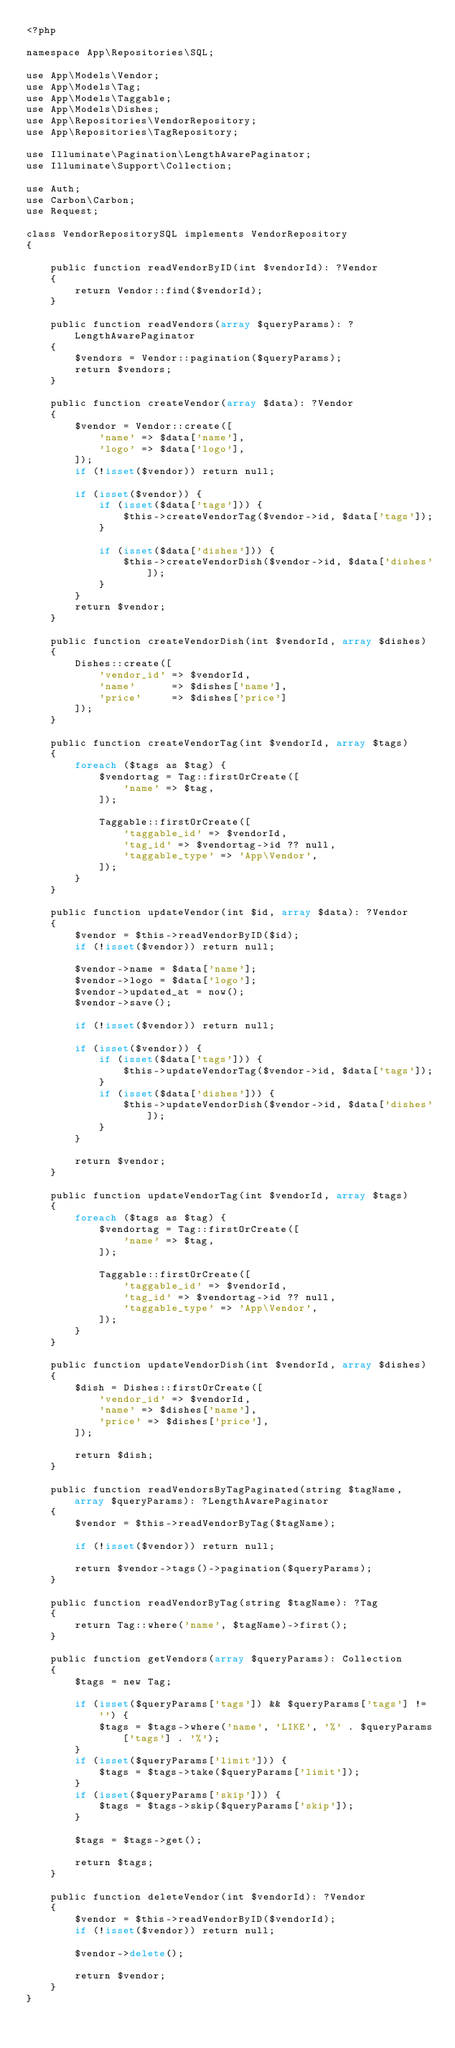<code> <loc_0><loc_0><loc_500><loc_500><_PHP_><?php

namespace App\Repositories\SQL;

use App\Models\Vendor;
use App\Models\Tag;
use App\Models\Taggable;
use App\Models\Dishes;
use App\Repositories\VendorRepository;
use App\Repositories\TagRepository;

use Illuminate\Pagination\LengthAwarePaginator;
use Illuminate\Support\Collection;

use Auth;
use Carbon\Carbon;
use Request;

class VendorRepositorySQL implements VendorRepository
{

    public function readVendorByID(int $vendorId): ?Vendor
    {
        return Vendor::find($vendorId);
    }

    public function readVendors(array $queryParams): ?LengthAwarePaginator
    {
        $vendors = Vendor::pagination($queryParams);
        return $vendors;
    }

    public function createVendor(array $data): ?Vendor
    {
        $vendor = Vendor::create([
            'name' => $data['name'],
            'logo' => $data['logo'],
        ]);
        if (!isset($vendor)) return null;

        if (isset($vendor)) {
            if (isset($data['tags'])) {
                $this->createVendorTag($vendor->id, $data['tags']);
            }

            if (isset($data['dishes'])) {
                $this->createVendorDish($vendor->id, $data['dishes']);
            }
        }
        return $vendor;
    }

    public function createVendorDish(int $vendorId, array $dishes)
    {
        Dishes::create([
            'vendor_id' => $vendorId,
            'name'      => $dishes['name'],
            'price'     => $dishes['price']
        ]);
    }

    public function createVendorTag(int $vendorId, array $tags)
    {
        foreach ($tags as $tag) {
            $vendortag = Tag::firstOrCreate([
                'name' => $tag,
            ]);

            Taggable::firstOrCreate([
                'taggable_id' => $vendorId,
                'tag_id' => $vendortag->id ?? null,
                'taggable_type' => 'App\Vendor',
            ]);
        }
    }

    public function updateVendor(int $id, array $data): ?Vendor
    {
        $vendor = $this->readVendorByID($id);
        if (!isset($vendor)) return null;

        $vendor->name = $data['name'];
        $vendor->logo = $data['logo'];
        $vendor->updated_at = now();
        $vendor->save();

        if (!isset($vendor)) return null;

        if (isset($vendor)) {
            if (isset($data['tags'])) {
                $this->updateVendorTag($vendor->id, $data['tags']);
            }
            if (isset($data['dishes'])) {
                $this->updateVendorDish($vendor->id, $data['dishes']);
            }
        }

        return $vendor;
    }

    public function updateVendorTag(int $vendorId, array $tags)
    {
        foreach ($tags as $tag) {
            $vendortag = Tag::firstOrCreate([
                'name' => $tag,
            ]);

            Taggable::firstOrCreate([
                'taggable_id' => $vendorId,
                'tag_id' => $vendortag->id ?? null,
                'taggable_type' => 'App\Vendor',
            ]);
        }
    }

    public function updateVendorDish(int $vendorId, array $dishes)
    {
        $dish = Dishes::firstOrCreate([
            'vendor_id' => $vendorId,
            'name' => $dishes['name'],
            'price' => $dishes['price'],
        ]);

        return $dish;
    }

    public function readVendorsByTagPaginated(string $tagName, array $queryParams): ?LengthAwarePaginator
    {
        $vendor = $this->readVendorByTag($tagName);

        if (!isset($vendor)) return null;

        return $vendor->tags()->pagination($queryParams);
    }

    public function readVendorByTag(string $tagName): ?Tag
    {
        return Tag::where('name', $tagName)->first();
    }

    public function getVendors(array $queryParams): Collection
    {
        $tags = new Tag;

        if (isset($queryParams['tags']) && $queryParams['tags'] != '') {
            $tags = $tags->where('name', 'LIKE', '%' . $queryParams['tags'] . '%');
        }
        if (isset($queryParams['limit'])) {
            $tags = $tags->take($queryParams['limit']);
        }
        if (isset($queryParams['skip'])) {
            $tags = $tags->skip($queryParams['skip']);
        }

        $tags = $tags->get();

        return $tags;
    }

    public function deleteVendor(int $vendorId): ?Vendor
    {
        $vendor = $this->readVendorByID($vendorId);
        if (!isset($vendor)) return null;

        $vendor->delete();

        return $vendor;
    }
}
</code> 